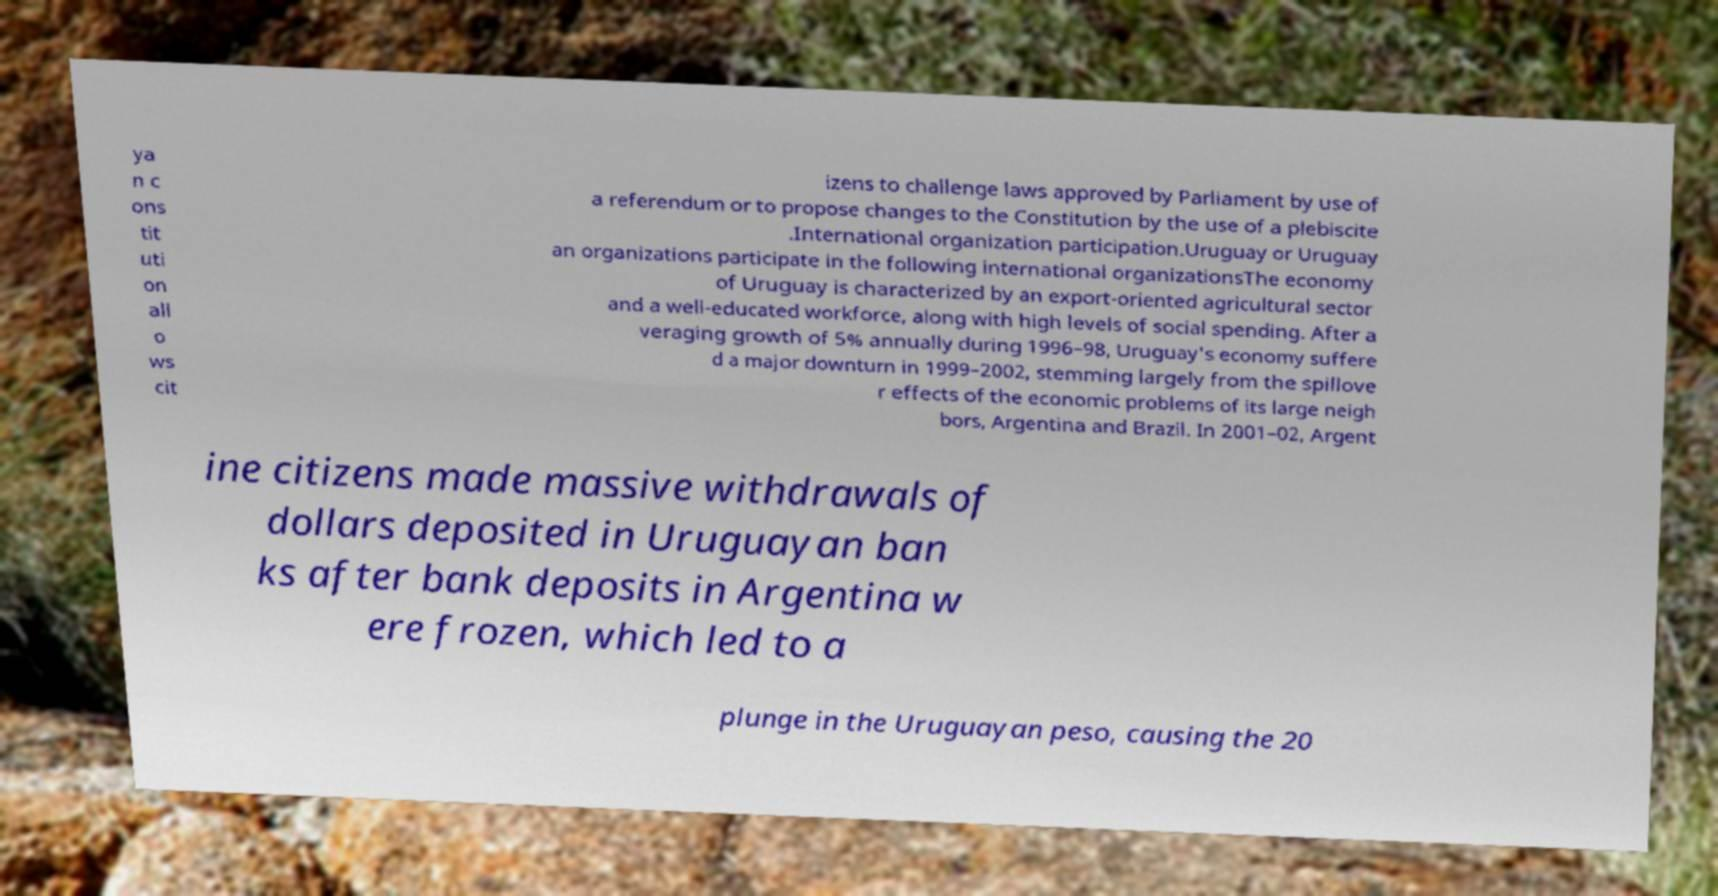Please identify and transcribe the text found in this image. ya n c ons tit uti on all o ws cit izens to challenge laws approved by Parliament by use of a referendum or to propose changes to the Constitution by the use of a plebiscite .International organization participation.Uruguay or Uruguay an organizations participate in the following international organizationsThe economy of Uruguay is characterized by an export-oriented agricultural sector and a well-educated workforce, along with high levels of social spending. After a veraging growth of 5% annually during 1996–98, Uruguay's economy suffere d a major downturn in 1999–2002, stemming largely from the spillove r effects of the economic problems of its large neigh bors, Argentina and Brazil. In 2001–02, Argent ine citizens made massive withdrawals of dollars deposited in Uruguayan ban ks after bank deposits in Argentina w ere frozen, which led to a plunge in the Uruguayan peso, causing the 20 